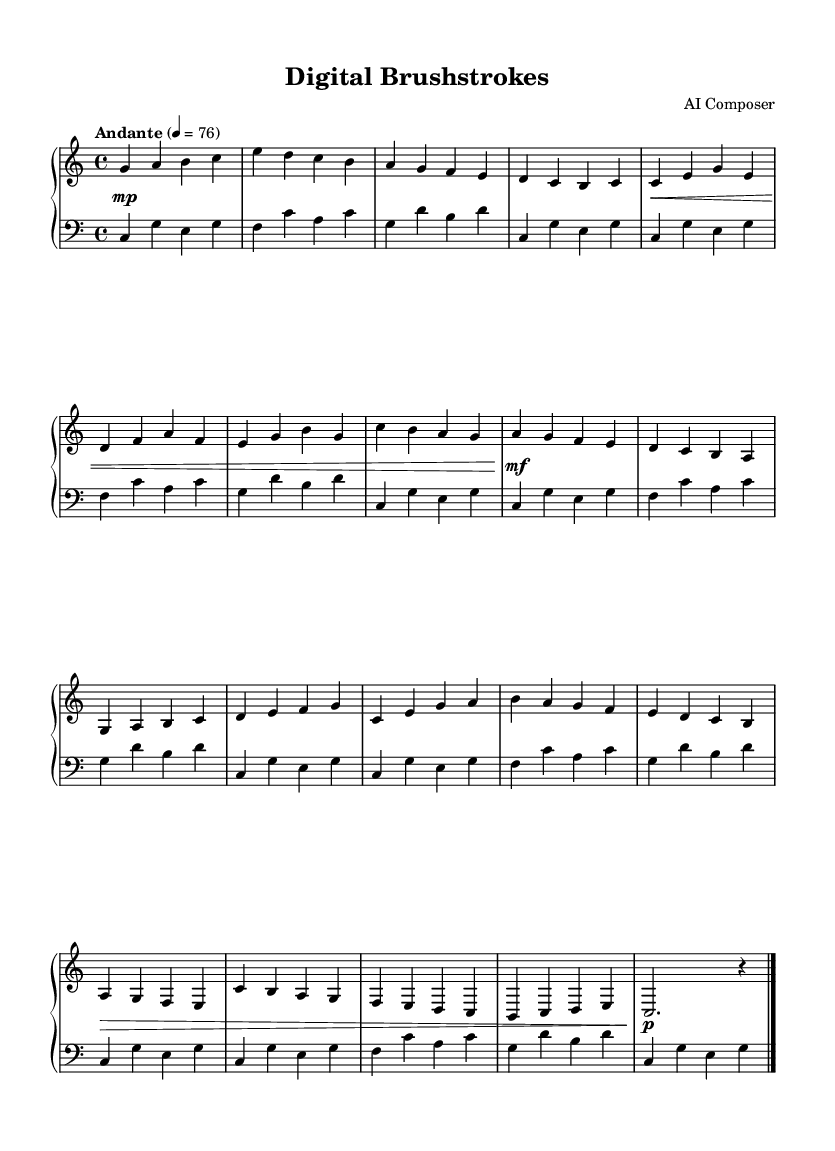What is the key signature of this music? The key signature is C major, which is indicated at the beginning of the score with no sharps or flats.
Answer: C major What is the time signature of this piece? The time signature is 4/4, which is shown at the beginning of the score, indicating four beats per measure.
Answer: 4/4 What is the tempo marking given for the piece? The tempo marking is "Andante," which indicates a moderate pace. The number 76 indicates the beats per minute.
Answer: Andante How many measures are in Section A? Section A consists of two main phrases, each with four measures, totaling eight measures.
Answer: 8 What is the dynamic marking for the first section? The dynamic marking starts with a piano (mp) indicating a soft volume initially, followed by crescendos and other dynamics throughout the piece.
Answer: mp In which measure does Section B start? Section B starts in measure 9, as the counting continues from the previous section.
Answer: 9 What is the final note of the piece? The final note of the piece is a half-note "C" followed by a rest. This indicates the conclusion of the composition.
Answer: C 